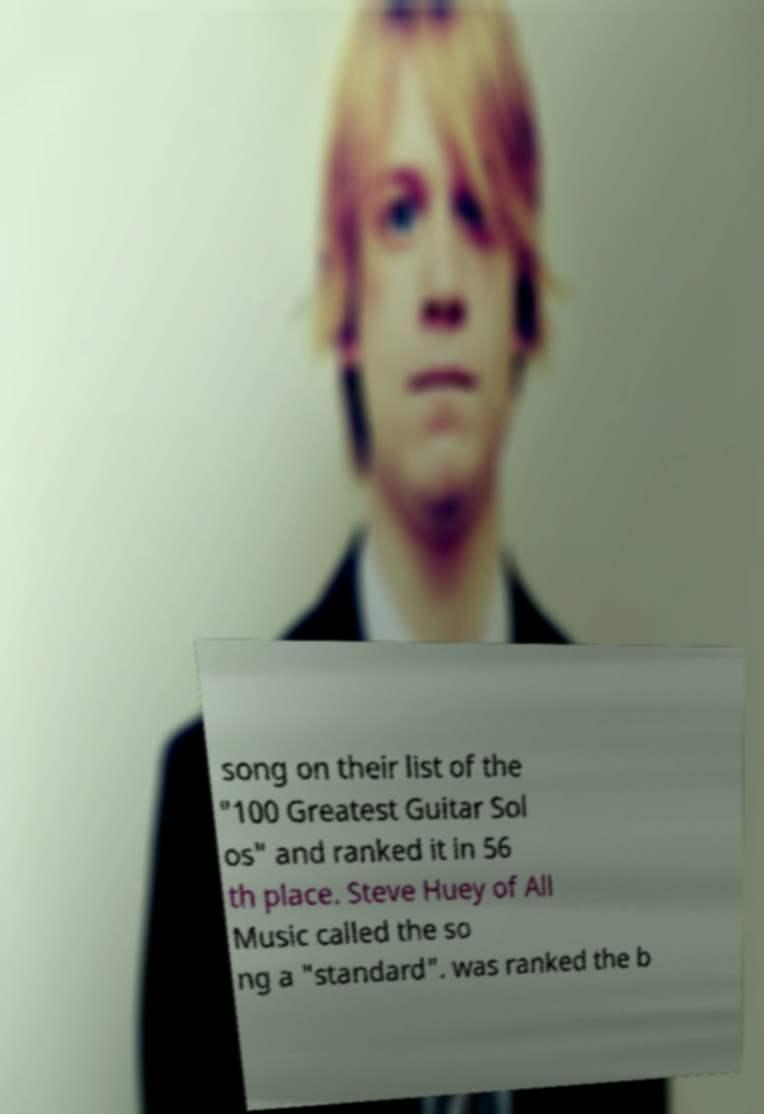Please identify and transcribe the text found in this image. song on their list of the "100 Greatest Guitar Sol os" and ranked it in 56 th place. Steve Huey of All Music called the so ng a "standard". was ranked the b 